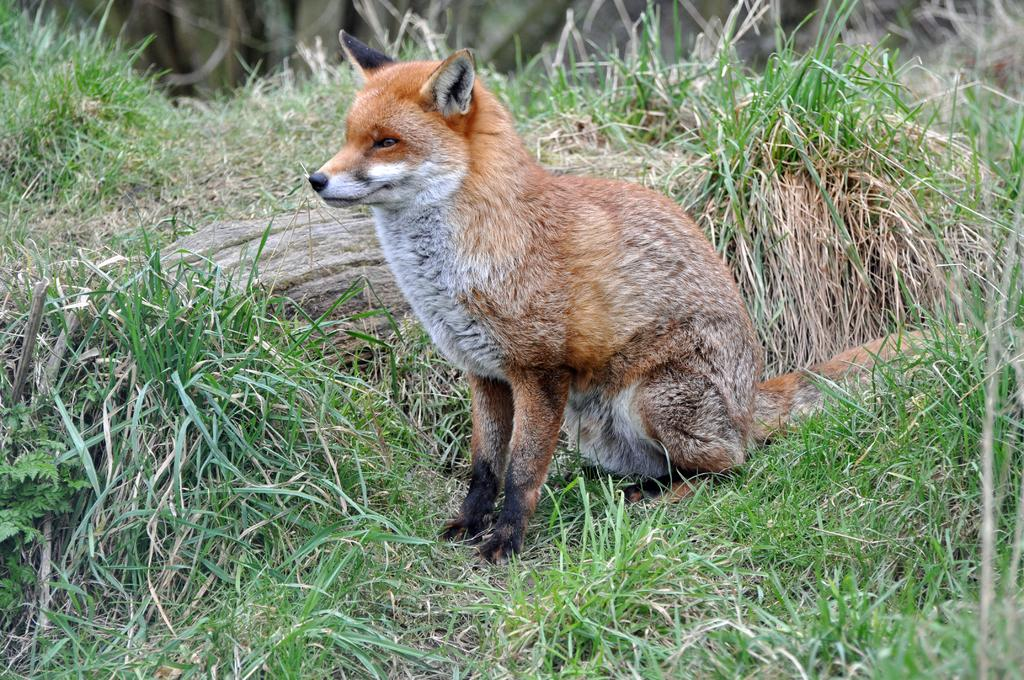What type of creature is in the image? There is an animal in the image. What color is the animal? The animal is brown in color. What is the animal doing in the image? The animal is sitting on the ground. What type of vegetation is present in the image? There is grass in the image. What color is the grass? The grass is green in color. Is the animal standing in quicksand in the image? There is no quicksand present in the image, and the animal is sitting on the ground, not standing in any substance. 